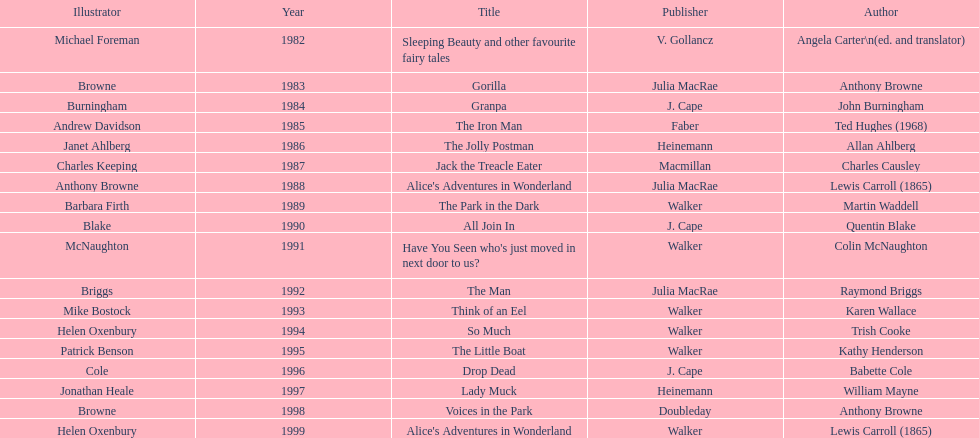How many titles had the same author listed as the illustrator? 7. Could you parse the entire table? {'header': ['Illustrator', 'Year', 'Title', 'Publisher', 'Author'], 'rows': [['Michael Foreman', '1982', 'Sleeping Beauty and other favourite fairy tales', 'V. Gollancz', 'Angela Carter\\n(ed. and translator)'], ['Browne', '1983', 'Gorilla', 'Julia MacRae', 'Anthony Browne'], ['Burningham', '1984', 'Granpa', 'J. Cape', 'John Burningham'], ['Andrew Davidson', '1985', 'The Iron Man', 'Faber', 'Ted Hughes (1968)'], ['Janet Ahlberg', '1986', 'The Jolly Postman', 'Heinemann', 'Allan Ahlberg'], ['Charles Keeping', '1987', 'Jack the Treacle Eater', 'Macmillan', 'Charles Causley'], ['Anthony Browne', '1988', "Alice's Adventures in Wonderland", 'Julia MacRae', 'Lewis Carroll (1865)'], ['Barbara Firth', '1989', 'The Park in the Dark', 'Walker', 'Martin Waddell'], ['Blake', '1990', 'All Join In', 'J. Cape', 'Quentin Blake'], ['McNaughton', '1991', "Have You Seen who's just moved in next door to us?", 'Walker', 'Colin McNaughton'], ['Briggs', '1992', 'The Man', 'Julia MacRae', 'Raymond Briggs'], ['Mike Bostock', '1993', 'Think of an Eel', 'Walker', 'Karen Wallace'], ['Helen Oxenbury', '1994', 'So Much', 'Walker', 'Trish Cooke'], ['Patrick Benson', '1995', 'The Little Boat', 'Walker', 'Kathy Henderson'], ['Cole', '1996', 'Drop Dead', 'J. Cape', 'Babette Cole'], ['Jonathan Heale', '1997', 'Lady Muck', 'Heinemann', 'William Mayne'], ['Browne', '1998', 'Voices in the Park', 'Doubleday', 'Anthony Browne'], ['Helen Oxenbury', '1999', "Alice's Adventures in Wonderland", 'Walker', 'Lewis Carroll (1865)']]} 